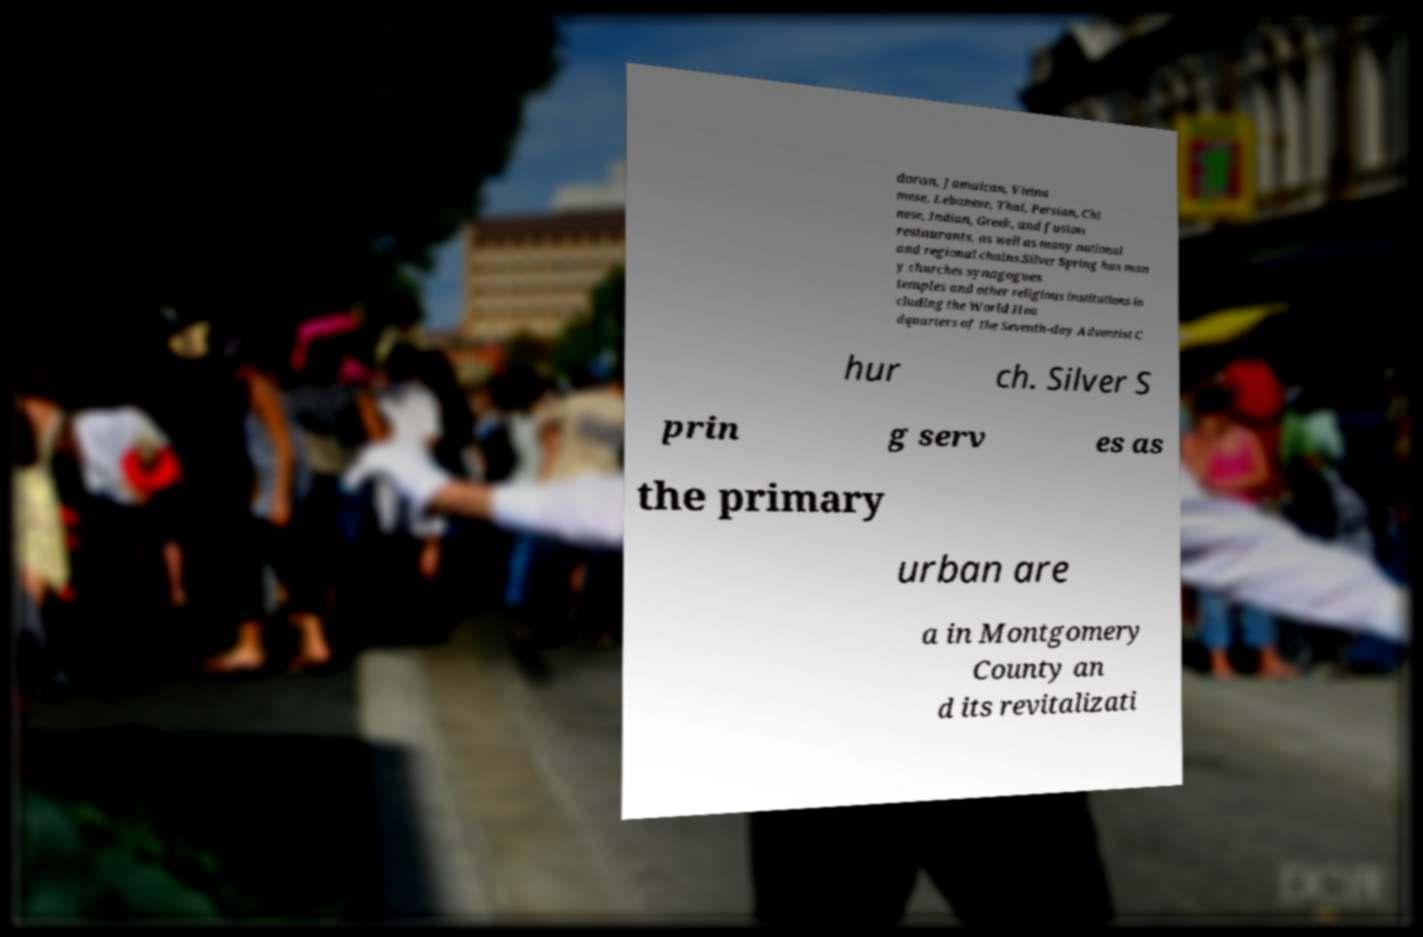I need the written content from this picture converted into text. Can you do that? doran, Jamaican, Vietna mese, Lebanese, Thai, Persian, Chi nese, Indian, Greek, and fusion restaurants, as well as many national and regional chains.Silver Spring has man y churches synagogues temples and other religious institutions in cluding the World Hea dquarters of the Seventh-day Adventist C hur ch. Silver S prin g serv es as the primary urban are a in Montgomery County an d its revitalizati 